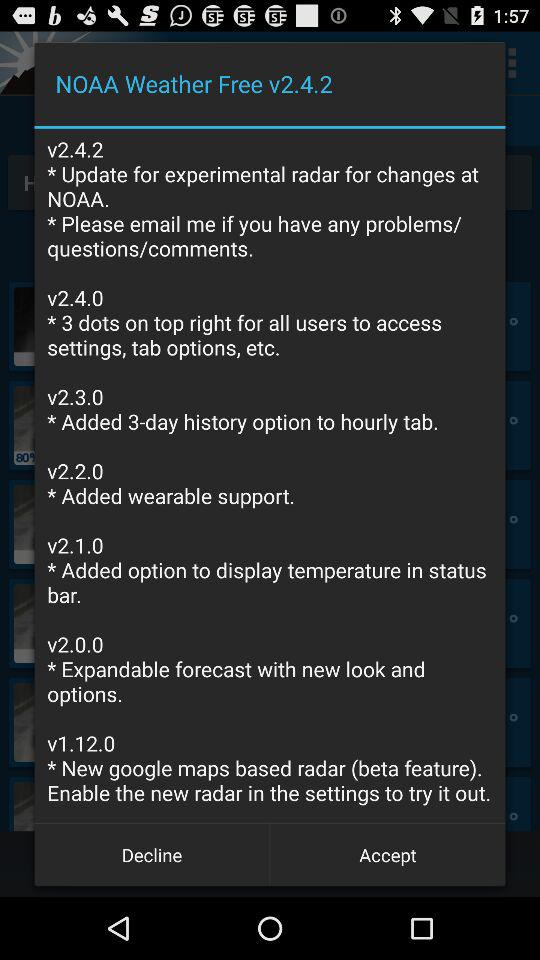What changes were made in version v2.4.0? The change made in version v2.4.0 was "3 dots on top right for all users to access settings, tab options, etc.". 